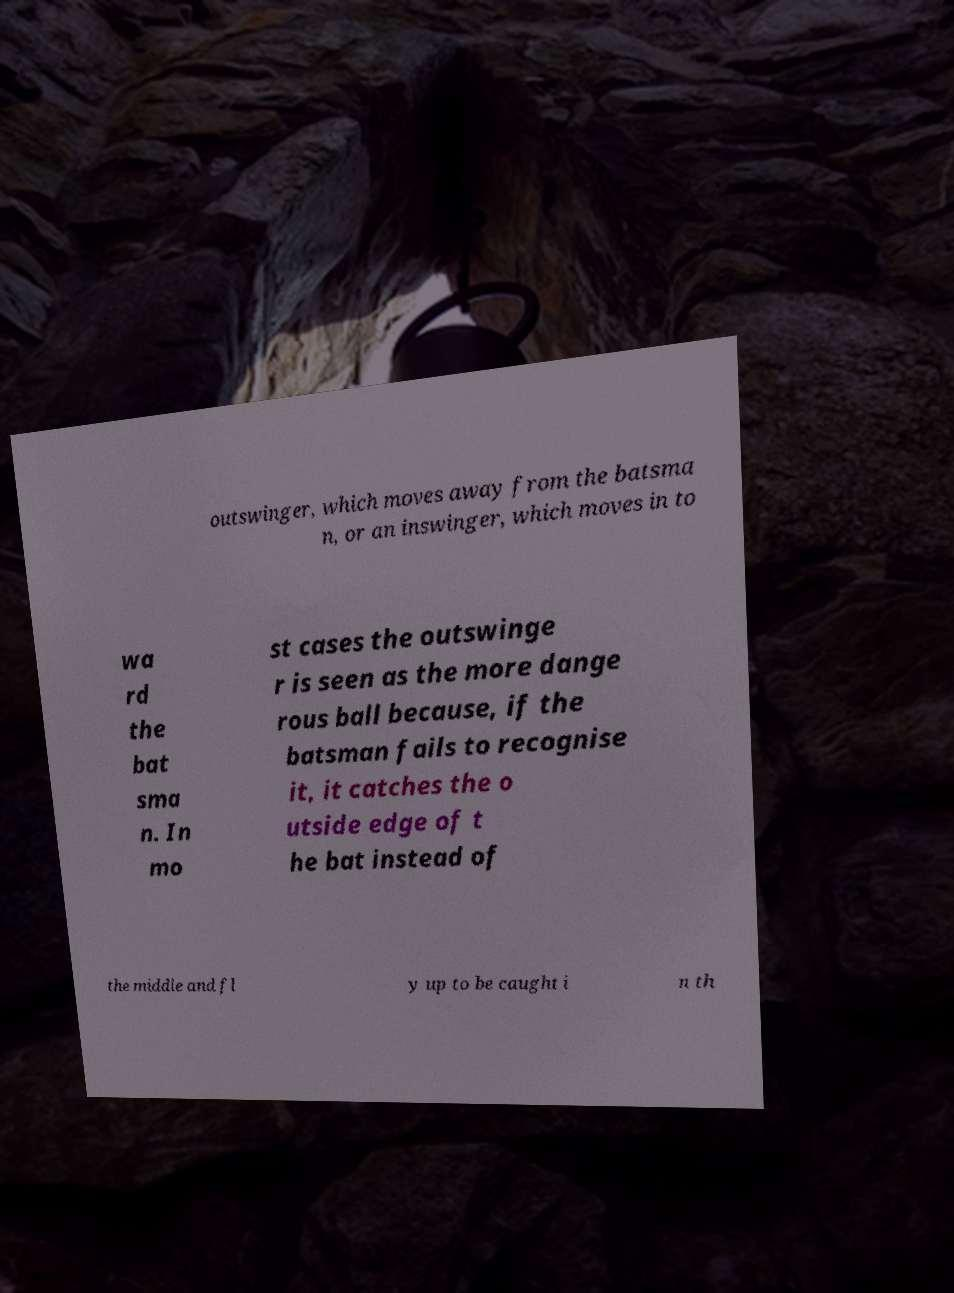There's text embedded in this image that I need extracted. Can you transcribe it verbatim? outswinger, which moves away from the batsma n, or an inswinger, which moves in to wa rd the bat sma n. In mo st cases the outswinge r is seen as the more dange rous ball because, if the batsman fails to recognise it, it catches the o utside edge of t he bat instead of the middle and fl y up to be caught i n th 